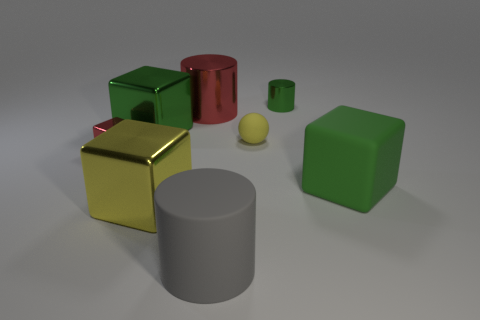There is a small thing that is the same color as the big rubber cube; what shape is it?
Provide a succinct answer. Cylinder. What material is the small cylinder that is the same color as the big rubber block?
Your answer should be compact. Metal. Is the tiny object on the left side of the small sphere made of the same material as the large block that is in front of the big green rubber thing?
Ensure brevity in your answer.  Yes. What is the yellow block made of?
Ensure brevity in your answer.  Metal. How many other objects are the same color as the large metallic cylinder?
Offer a very short reply. 1. Do the small matte sphere and the tiny metallic cube have the same color?
Your response must be concise. No. What number of small yellow spheres are there?
Provide a succinct answer. 1. There is a large block right of the small shiny cylinder on the right side of the big green shiny thing; what is its material?
Keep it short and to the point. Rubber. There is a yellow thing that is the same size as the red block; what is it made of?
Provide a succinct answer. Rubber. Do the green metal thing that is in front of the green cylinder and the yellow metallic block have the same size?
Provide a succinct answer. Yes. 